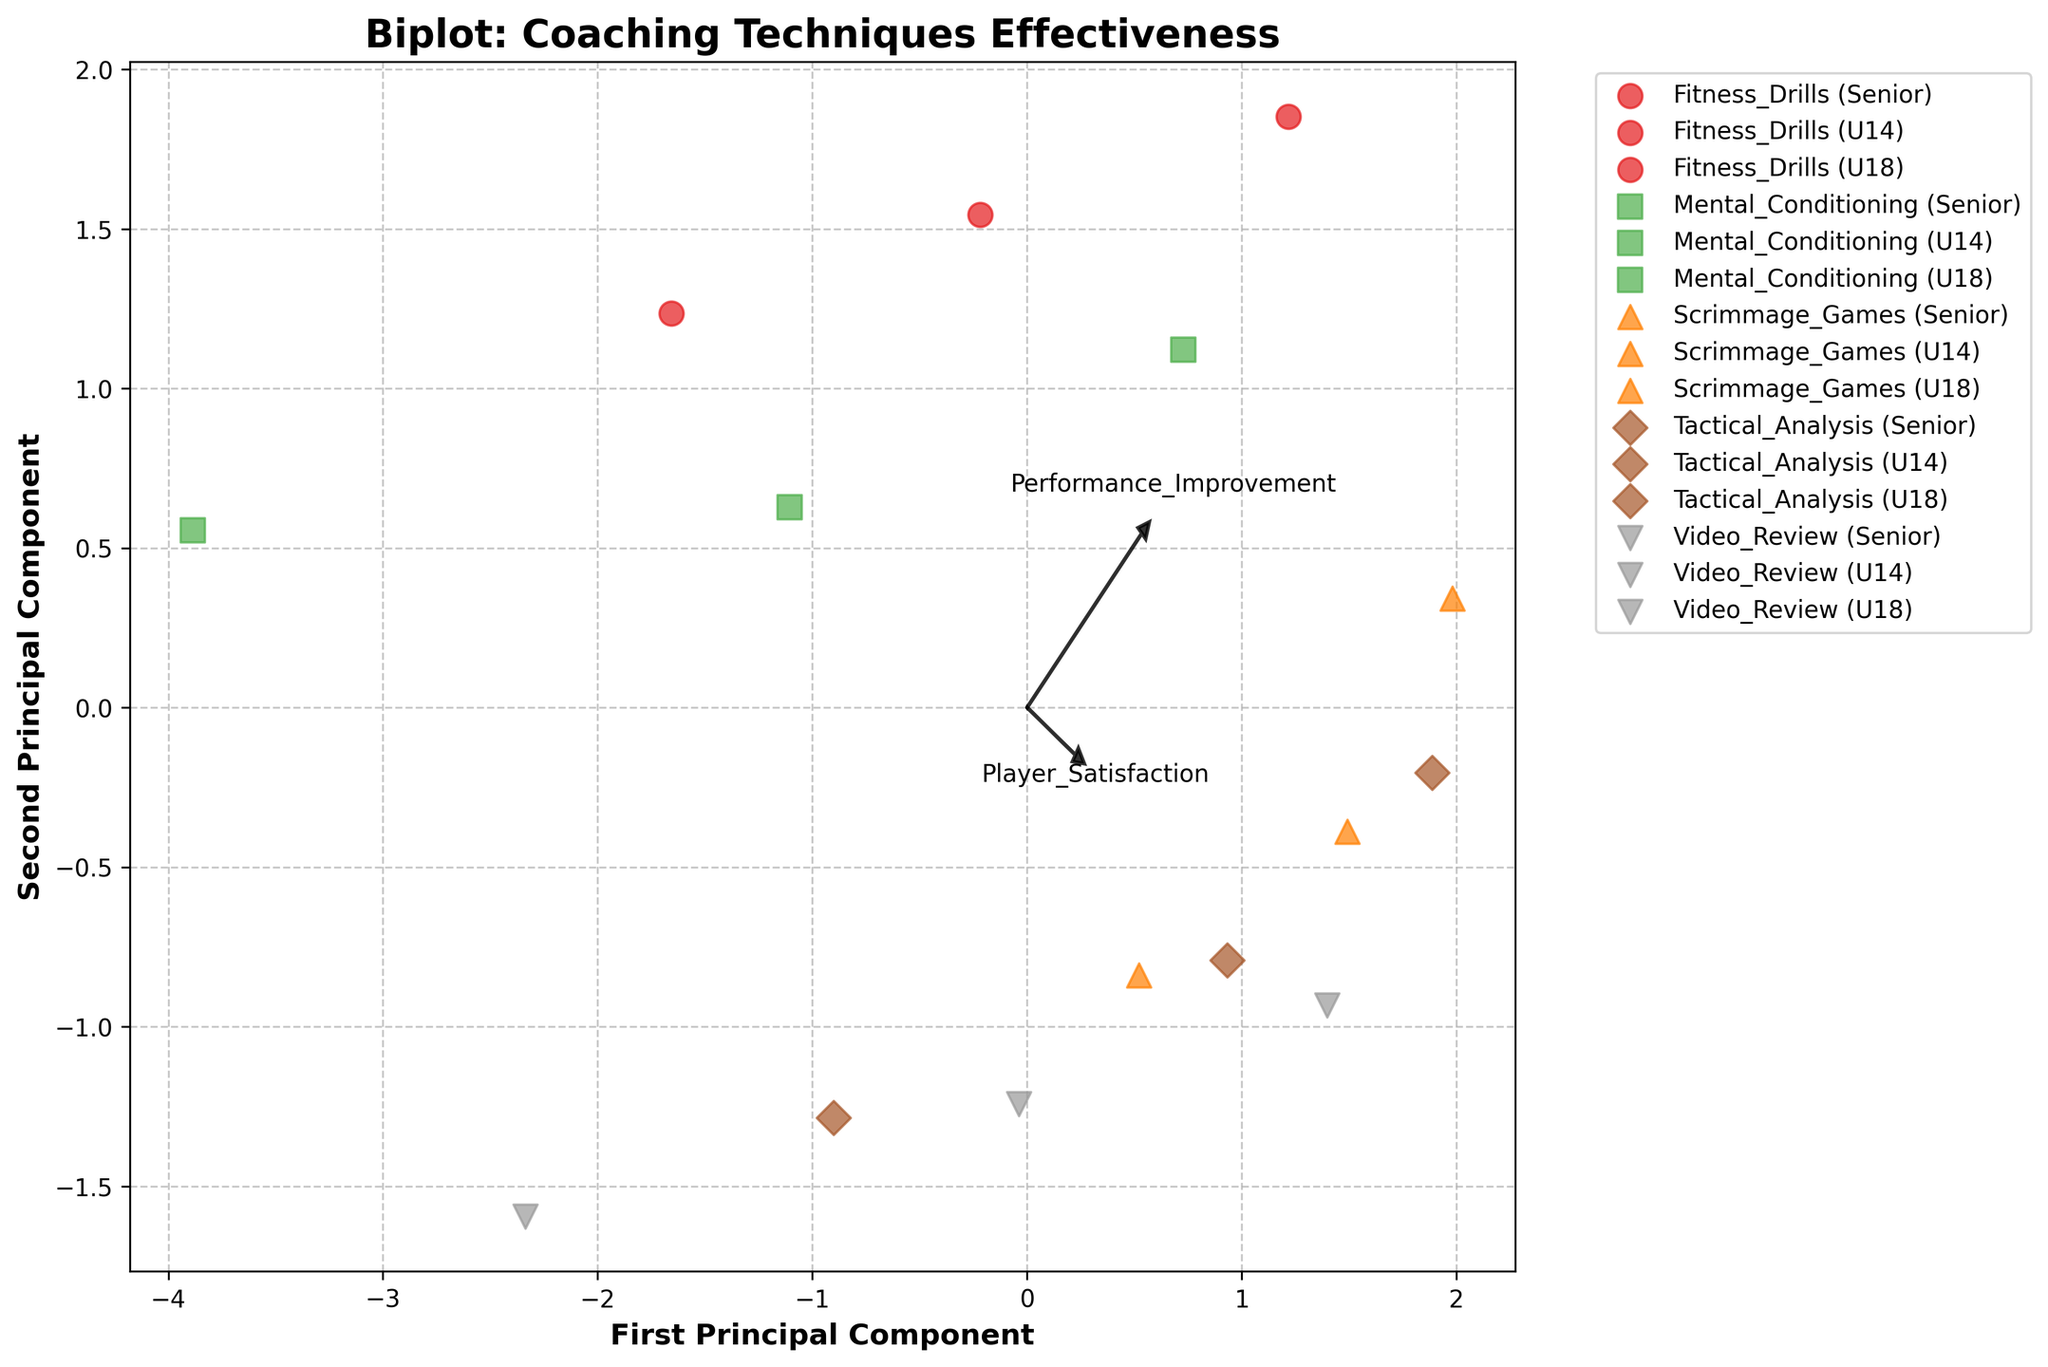What is the title of the figure? The title of the figure is usually found at the top of the plot where it describes what the plot is about.
Answer: 'Biplot: Coaching Techniques Effectiveness' Which technique shows the most improvement in the Senior age group? By observing the plot and identifying the data points labeled with "Senior," we can see which technique's data point lies furthest along the positive performance improvement axis.
Answer: 'Scrimmage_Games' Which age group generally has the highest player satisfaction? We look at data points representing each age group and compare their positions along the player satisfaction vector. The general trend should become clear.
Answer: 'Senior' How do mental conditioning techniques compare with tactical analysis in terms of skill development? By locating the Mental_Conditioning and Tactical_Analysis data points and observing their positions along the skill development vector, we can compare their values.
Answer: Tactical_analysis has higher skill development What is the primary direction of injury reduction? In a biplot, the direction of each vector represents the primary direction of that feature in the PCA space. The injury reduction vector's orientation indicates its direction.
Answer: Downward-left or negative direction Which feature has the highest impact on the first principal component? The first principal component axis runs horizontally. Features with vectors pointing more horizontally have a higher impact on this component.
Answer: 'Performance_Improvement' What is the general trend for fitness drills across different age groups? We look at data points for Fitness_Drills and observe their positions and variations across different age groups for all features.
Answer: Increases across age groups Do any techniques overlap in their PCA representation? If so, which ones? Techniques overlap if their PCA-transformed data points are plotted on top of one another or very close to each other on the plot.
Answer: No significant overlap Which feature seems to contribute equally to both principal components? A feature contributes equally to both principal components if its vector has roughly equal horizontal and vertical components.
Answer: 'Player_Satisfaction' Does the U14 age group show any outlier behavior for any technique? Identify the U14 age group data points across different techniques and check if any data point significantly deviates from the others in the PCA space.
Answer: 'Mental_Conditioning' for Performance_Improvement 